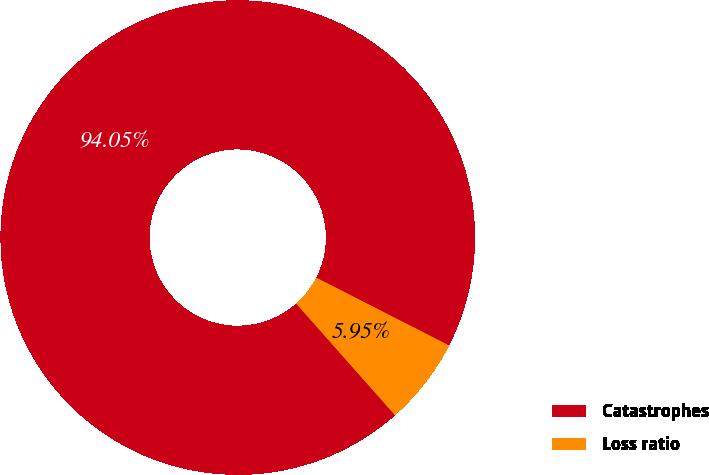Convert chart to OTSL. <chart><loc_0><loc_0><loc_500><loc_500><pie_chart><fcel>Catastrophes<fcel>Loss ratio<nl><fcel>94.05%<fcel>5.95%<nl></chart> 